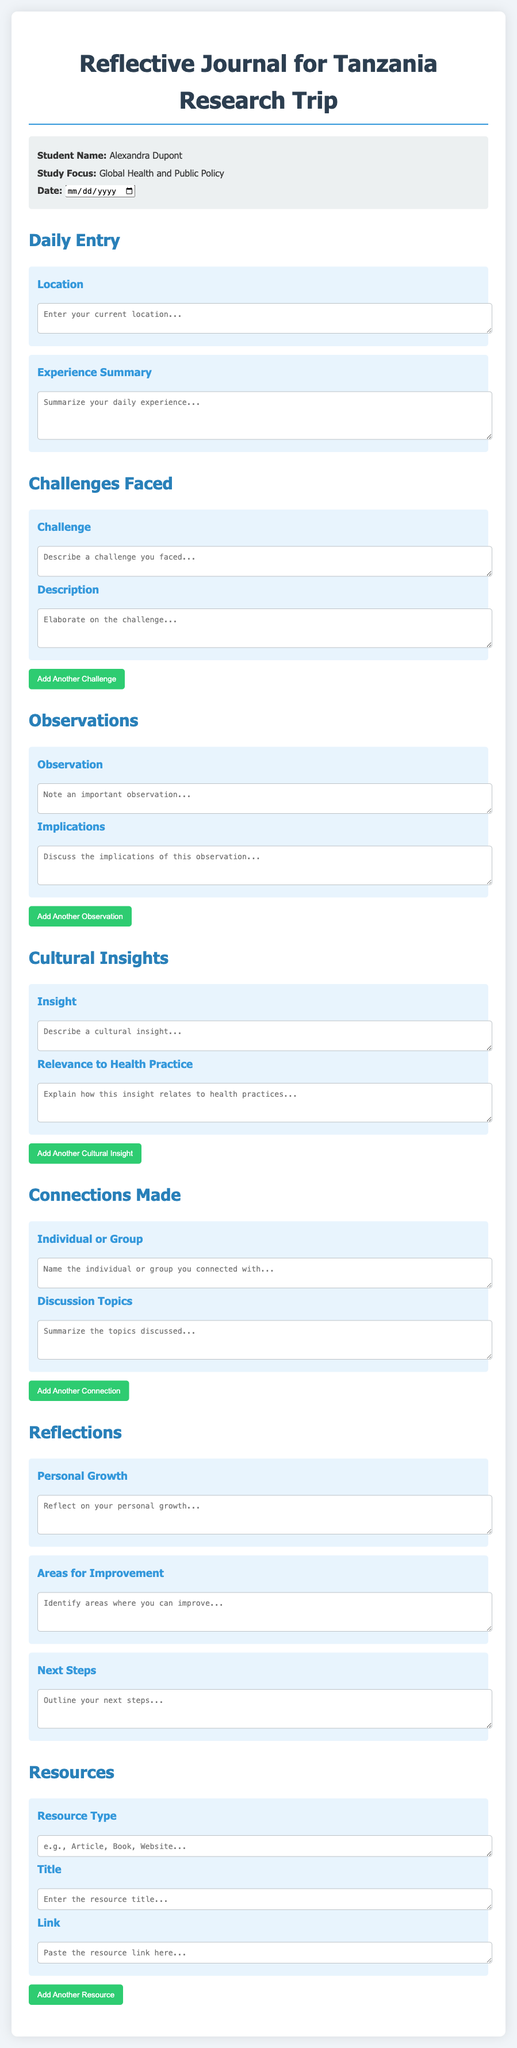What is the title of the document? The title is stated at the top of the document as "Reflective Journal for Tanzania Research Trip."
Answer: Reflective Journal for Tanzania Research Trip What is the name of the student? The student's name is included in the info section of the document.
Answer: Alexandra Dupont What is the study focus of the student? The study focus is mentioned in the info section along with the student's name.
Answer: Global Health and Public Policy What is the maximum number of rows for the "Experience Summary" section? The number of rows for the "Experience Summary" textarea is specified in the document as 4 rows.
Answer: 4 What are the three areas addressed in the Reflections section? The document lists three specific topics under the Reflections section that are to be addressed by the user.
Answer: Personal Growth, Areas for Improvement, Next Steps How many entry sections are there in the journal template? The total number of distinct entry sections can be counted from the document.
Answer: 6 What type of button is provided to add more challenges, observations, cultural insights, connections, or resources? The document describes a button used in multiple sections.
Answer: Add Another What is the color of the main text in the document? The main text color is defined in the style section of the document.
Answer: #333 What kind of inputs are in the Resources section for the resource details? The document includes several types of inputs for resources including title, type, and link.
Answer: Resource Type, Title, Link 